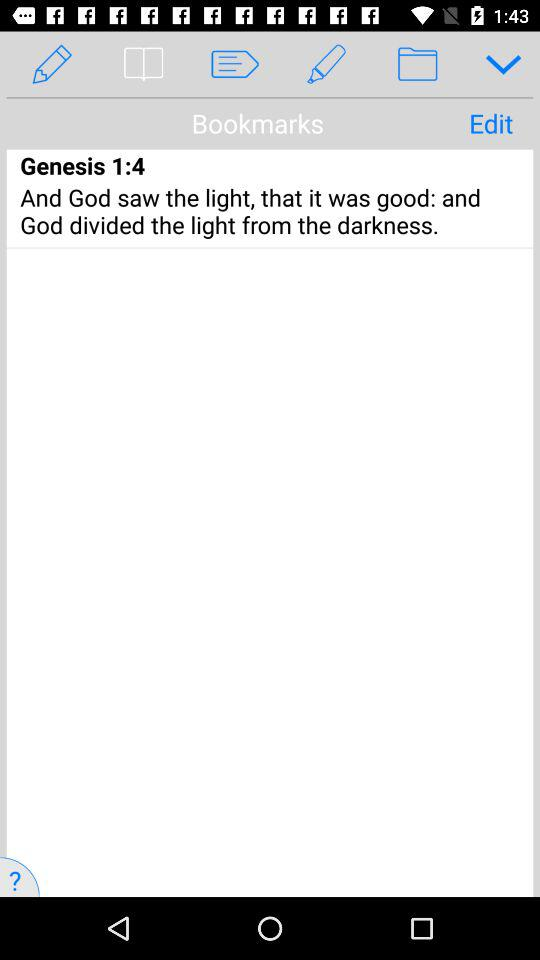Who divided the light from the darkness? The light is divided from the darkness by "God". 